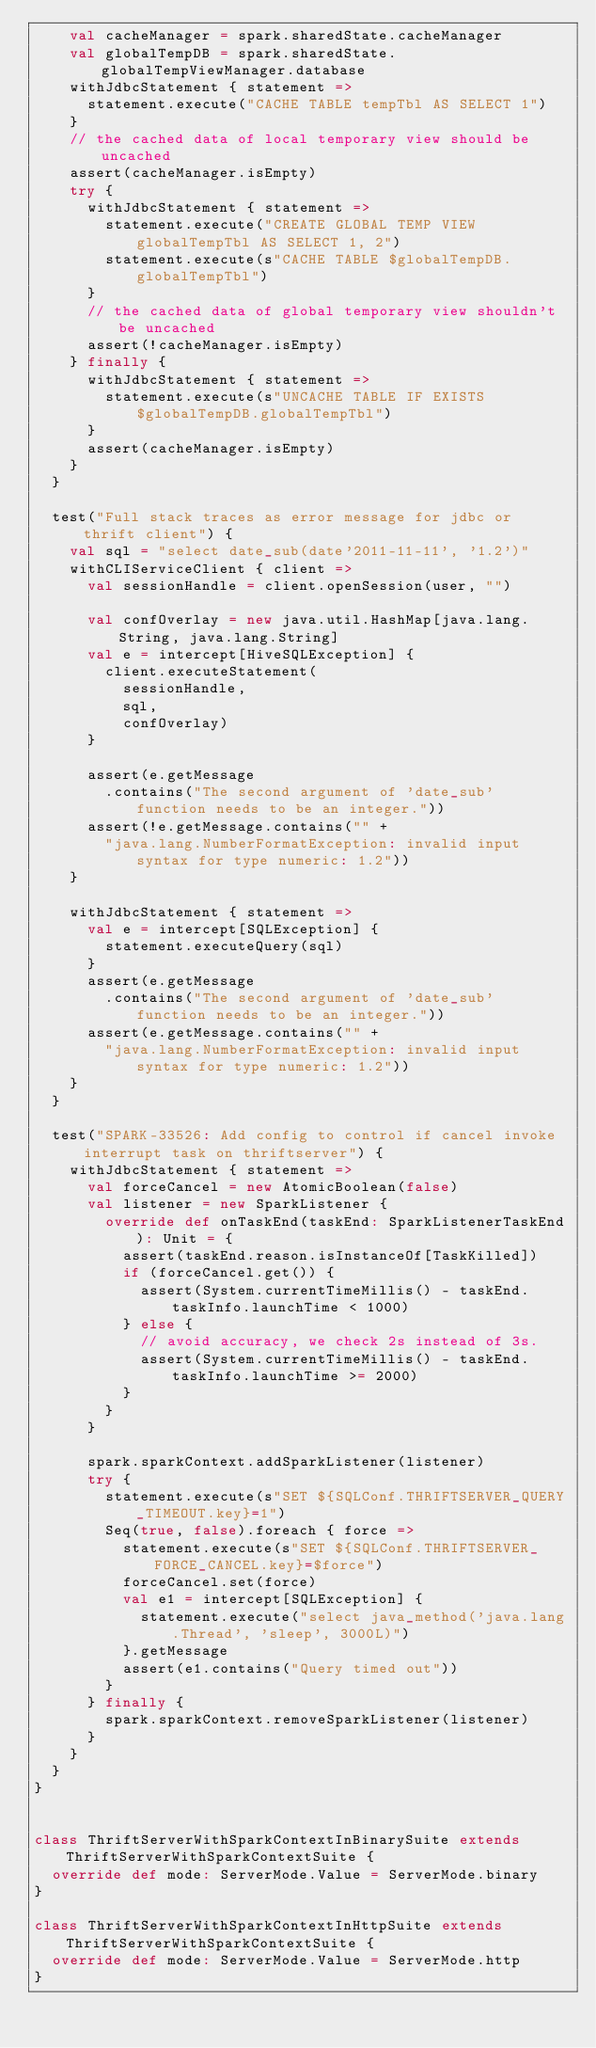<code> <loc_0><loc_0><loc_500><loc_500><_Scala_>    val cacheManager = spark.sharedState.cacheManager
    val globalTempDB = spark.sharedState.globalTempViewManager.database
    withJdbcStatement { statement =>
      statement.execute("CACHE TABLE tempTbl AS SELECT 1")
    }
    // the cached data of local temporary view should be uncached
    assert(cacheManager.isEmpty)
    try {
      withJdbcStatement { statement =>
        statement.execute("CREATE GLOBAL TEMP VIEW globalTempTbl AS SELECT 1, 2")
        statement.execute(s"CACHE TABLE $globalTempDB.globalTempTbl")
      }
      // the cached data of global temporary view shouldn't be uncached
      assert(!cacheManager.isEmpty)
    } finally {
      withJdbcStatement { statement =>
        statement.execute(s"UNCACHE TABLE IF EXISTS $globalTempDB.globalTempTbl")
      }
      assert(cacheManager.isEmpty)
    }
  }

  test("Full stack traces as error message for jdbc or thrift client") {
    val sql = "select date_sub(date'2011-11-11', '1.2')"
    withCLIServiceClient { client =>
      val sessionHandle = client.openSession(user, "")

      val confOverlay = new java.util.HashMap[java.lang.String, java.lang.String]
      val e = intercept[HiveSQLException] {
        client.executeStatement(
          sessionHandle,
          sql,
          confOverlay)
      }

      assert(e.getMessage
        .contains("The second argument of 'date_sub' function needs to be an integer."))
      assert(!e.getMessage.contains("" +
        "java.lang.NumberFormatException: invalid input syntax for type numeric: 1.2"))
    }

    withJdbcStatement { statement =>
      val e = intercept[SQLException] {
        statement.executeQuery(sql)
      }
      assert(e.getMessage
        .contains("The second argument of 'date_sub' function needs to be an integer."))
      assert(e.getMessage.contains("" +
        "java.lang.NumberFormatException: invalid input syntax for type numeric: 1.2"))
    }
  }

  test("SPARK-33526: Add config to control if cancel invoke interrupt task on thriftserver") {
    withJdbcStatement { statement =>
      val forceCancel = new AtomicBoolean(false)
      val listener = new SparkListener {
        override def onTaskEnd(taskEnd: SparkListenerTaskEnd): Unit = {
          assert(taskEnd.reason.isInstanceOf[TaskKilled])
          if (forceCancel.get()) {
            assert(System.currentTimeMillis() - taskEnd.taskInfo.launchTime < 1000)
          } else {
            // avoid accuracy, we check 2s instead of 3s.
            assert(System.currentTimeMillis() - taskEnd.taskInfo.launchTime >= 2000)
          }
        }
      }

      spark.sparkContext.addSparkListener(listener)
      try {
        statement.execute(s"SET ${SQLConf.THRIFTSERVER_QUERY_TIMEOUT.key}=1")
        Seq(true, false).foreach { force =>
          statement.execute(s"SET ${SQLConf.THRIFTSERVER_FORCE_CANCEL.key}=$force")
          forceCancel.set(force)
          val e1 = intercept[SQLException] {
            statement.execute("select java_method('java.lang.Thread', 'sleep', 3000L)")
          }.getMessage
          assert(e1.contains("Query timed out"))
        }
      } finally {
        spark.sparkContext.removeSparkListener(listener)
      }
    }
  }
}


class ThriftServerWithSparkContextInBinarySuite extends ThriftServerWithSparkContextSuite {
  override def mode: ServerMode.Value = ServerMode.binary
}

class ThriftServerWithSparkContextInHttpSuite extends ThriftServerWithSparkContextSuite {
  override def mode: ServerMode.Value = ServerMode.http
}
</code> 